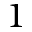Convert formula to latex. <formula><loc_0><loc_0><loc_500><loc_500>1</formula> 